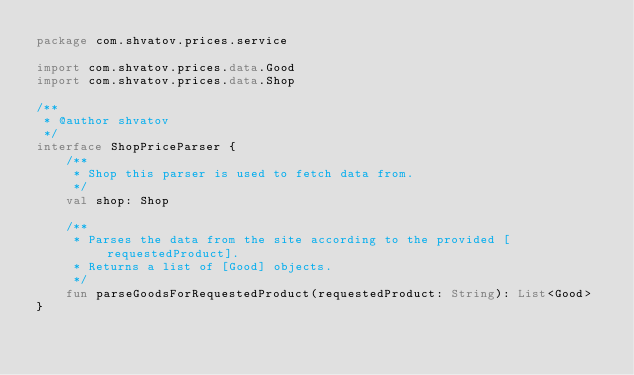Convert code to text. <code><loc_0><loc_0><loc_500><loc_500><_Kotlin_>package com.shvatov.prices.service

import com.shvatov.prices.data.Good
import com.shvatov.prices.data.Shop

/**
 * @author shvatov
 */
interface ShopPriceParser {
    /**
     * Shop this parser is used to fetch data from.
     */
    val shop: Shop

    /**
     * Parses the data from the site according to the provided [requestedProduct].
     * Returns a list of [Good] objects.
     */
    fun parseGoodsForRequestedProduct(requestedProduct: String): List<Good>
}</code> 